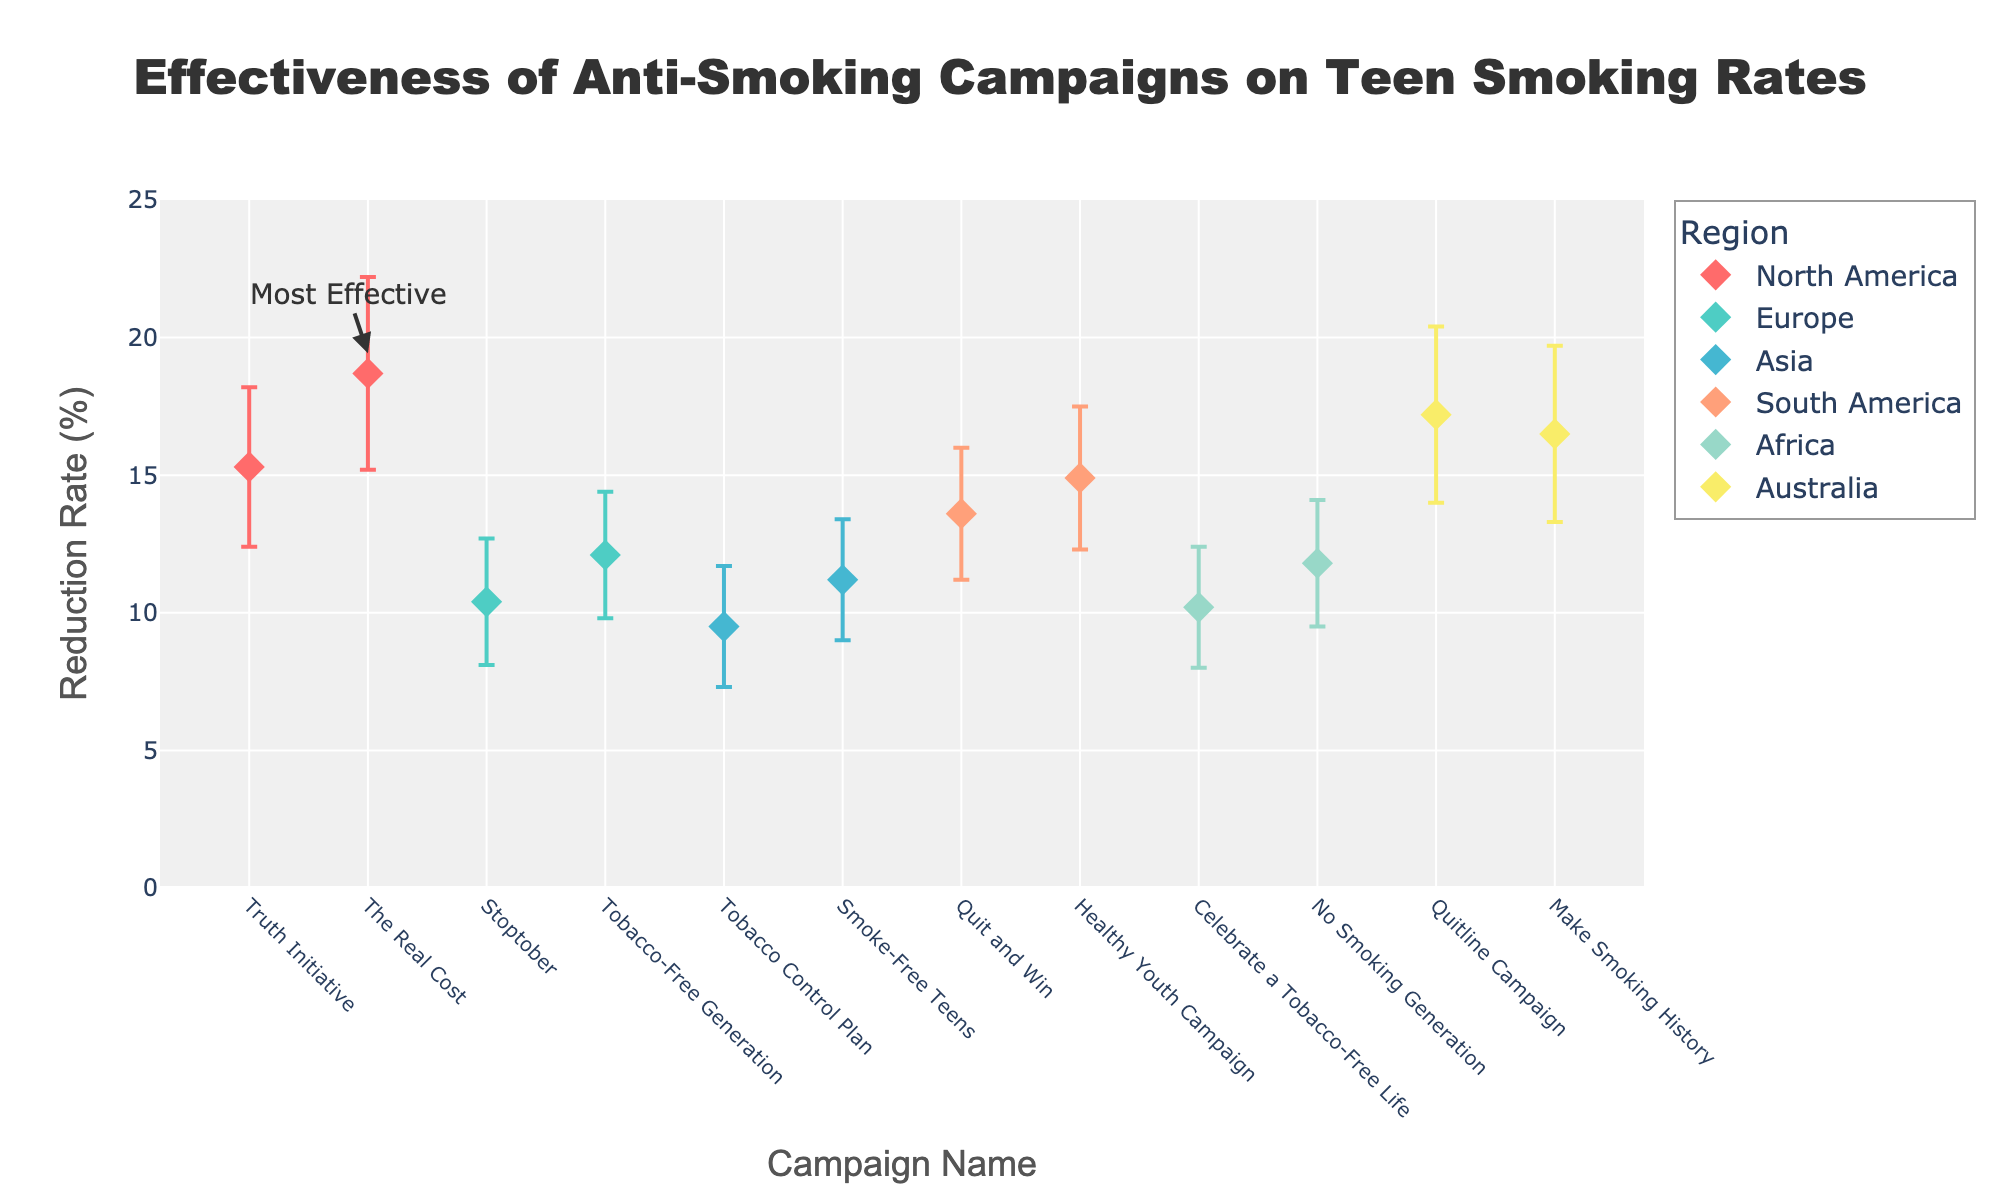What's the title of the figure? The title is always positioned at the top of the chart, often in bold or larger font. Here, the title is centered above the chart, which describes the content succinctly.
Answer: Effectiveness of Anti-Smoking Campaigns on Teen Smoking Rates What is the reduction rate of the "Quitline Campaign" in Australia? Locate "Quitline Campaign" along the x-axis, and trace vertically to the corresponding point, then check the y-axis value for reduction rate.
Answer: 17.2% Which campaign has the highest reduction rate? Identify the highest point on the y-axis and note the corresponding campaign on the x-axis.
Answer: The Real Cost How many campaigns are plotted for Europe? Count the number of markers within the "Europe" legend group. Each marker represents a campaign in that region.
Answer: 2 What is the confidence interval for the "Truth Initiative" campaign in North America? Find the "Truth Initiative" on the x-axis. The confidence interval is represented by the error bars extending vertically from the point. Note the lower and upper bounds.
Answer: 12.4% to 18.2% Which campaign has the largest confidence interval, and what is its range? Look for the longest error bars on the chart, and identify the corresponding campaign and their lower and upper bounds. Calculate the range by subtracting the lower bound from the upper bound.
Answer: The Real Cost; 7.0% Compare the effectiveness of the "Smoke-Free Teens" campaign in Asia with the "Quit and Win" campaign in South America. Which is more effective? Locate both campaigns on the x-axis. Compare their points' positions on the y-axis. The higher point represents the more effective campaign.
Answer: Quit and Win What is the average reduction rate of campaigns in Africa? Identify both African campaigns, note their reduction rates, sum them, and divide by the number of campaigns. (10.2 + 11.8)/2
Answer: 11.0% If a new campaign in Europe had a reduction rate of 13%, how would its effectiveness compare to existing campaigns in that region? Compare the new campaign's reduction rate to the plotted points for Europe. Observe whether it falls higher, lower, or between other points.
Answer: Higher than Stoptober, lower than Tobacco-Free Generation Which campaign has the smallest confidence interval, and what is its range? Look for the shortest error bars on the chart, and identify the corresponding campaign and calculate the range.
Answer: Stoptober; 4.6% 